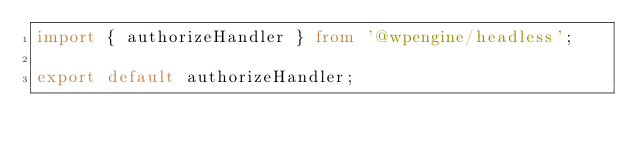Convert code to text. <code><loc_0><loc_0><loc_500><loc_500><_TypeScript_>import { authorizeHandler } from '@wpengine/headless';

export default authorizeHandler;
</code> 